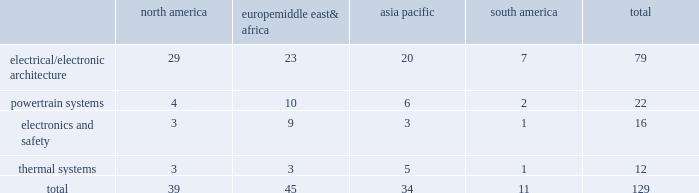Item 2 .
Properties as of december 31 , 2014 , we owned or leased 129 major manufacturing sites and 15 major technical centers in 33 countries .
A manufacturing site may include multiple plants and may be wholly or partially owned or leased .
We also have many smaller manufacturing sites , sales offices , warehouses , engineering centers , joint ventures and other investments strategically located throughout the world .
The table shows the regional distribution of our major manufacturing sites by the operating segment that uses such facilities : north america europe , middle east & africa asia pacific south america total .
In addition to these manufacturing sites , we had 15 major technical centers : five in north america ; five in europe , middle east and africa ; four in asia pacific ; and one in south america .
Of our 129 major manufacturing sites and 15 major technical centers , which include facilities owned or leased by our consolidated subsidiaries , 83 are primarily owned and 61 are primarily leased .
We frequently review our real estate portfolio and develop footprint strategies to support our customers 2019 global plans , while at the same time supporting our technical needs and controlling operating expenses .
We believe our evolving portfolio will meet current and anticipated future needs .
Item 3 .
Legal proceedings we are from time to time subject to various actions , claims , suits , government investigations , and other proceedings incidental to our business , including those arising out of alleged defects , breach of contracts , competition and antitrust matters , product warranties , intellectual property matters , personal injury claims and employment-related matters .
It is our opinion that the outcome of such matters will not have a material adverse impact on our consolidated financial position , results of operations , or cash flows .
With respect to warranty matters , although we cannot ensure that the future costs of warranty claims by customers will not be material , we believe our established reserves are adequate to cover potential warranty settlements .
However , the final amounts required to resolve these matters could differ materially from our recorded estimates .
Gm ignition switch recall in the first quarter of 2014 , gm , delphi 2019s largest customer , initiated a product recall related to ignition switches .
Delphi has received requests for information from , and is cooperating with , various government agencies related to this ignition switch recall .
In addition , delphi has been named as a co-defendant along with gm ( and in certain cases other parties ) in product liability and class action lawsuits related to this matter .
During the second quarter of 2014 , all of the class action cases were transferred to the united states district court for the southern district of new york ( the 201cdistrict court 201d ) for coordinated pretrial proceedings .
Two consolidated amended class action complaints were filed in the district court on october 14 , 2014 .
Delphi was not named as a defendant in either complaint .
Delphi believes the allegations contained in the product liability cases are without merit , and intends to vigorously defend against them .
Although no assurances can be made as to the ultimate outcome of these or any other future claims , delphi does not believe a loss is probable and , accordingly , no reserve has been made as of december 31 , 2014 .
Unsecured creditors litigation under the terms of the fourth amended and restated limited liability partnership agreement of delphi automotive llp ( the 201cfourth llp agreement 201d ) , if cumulative distributions to the members of delphi automotive llp under certain provisions of the fourth llp agreement exceed $ 7.2 billion , delphi , as disbursing agent on behalf of dphh , is required to pay to the holders of allowed general unsecured claims against old delphi , $ 32.50 for every $ 67.50 in excess of $ 7.2 billion distributed to the members , up to a maximum amount of $ 300 million .
In december 2014 , a complaint was filed in the bankruptcy court alleging that the redemption by delphi automotive llp of the membership interests of gm and the pbgc , and the repurchase of shares and payment of dividends by delphi automotive plc , constituted distributions under the terms of the fourth llp agreement approximating $ 7.2 billion .
Delphi considers cumulative distributions through december 31 , 2014 to be substantially below the $ 7.2 billion threshold , and intends to vigorously contest the allegations set forth in the complaint .
Accordingly , no accrual for this matter has been recorded as of december 31 , 2014. .
What percentage of major manufacturing sites are in asia pacific? 
Computations: (34 / 129)
Answer: 0.26357. 